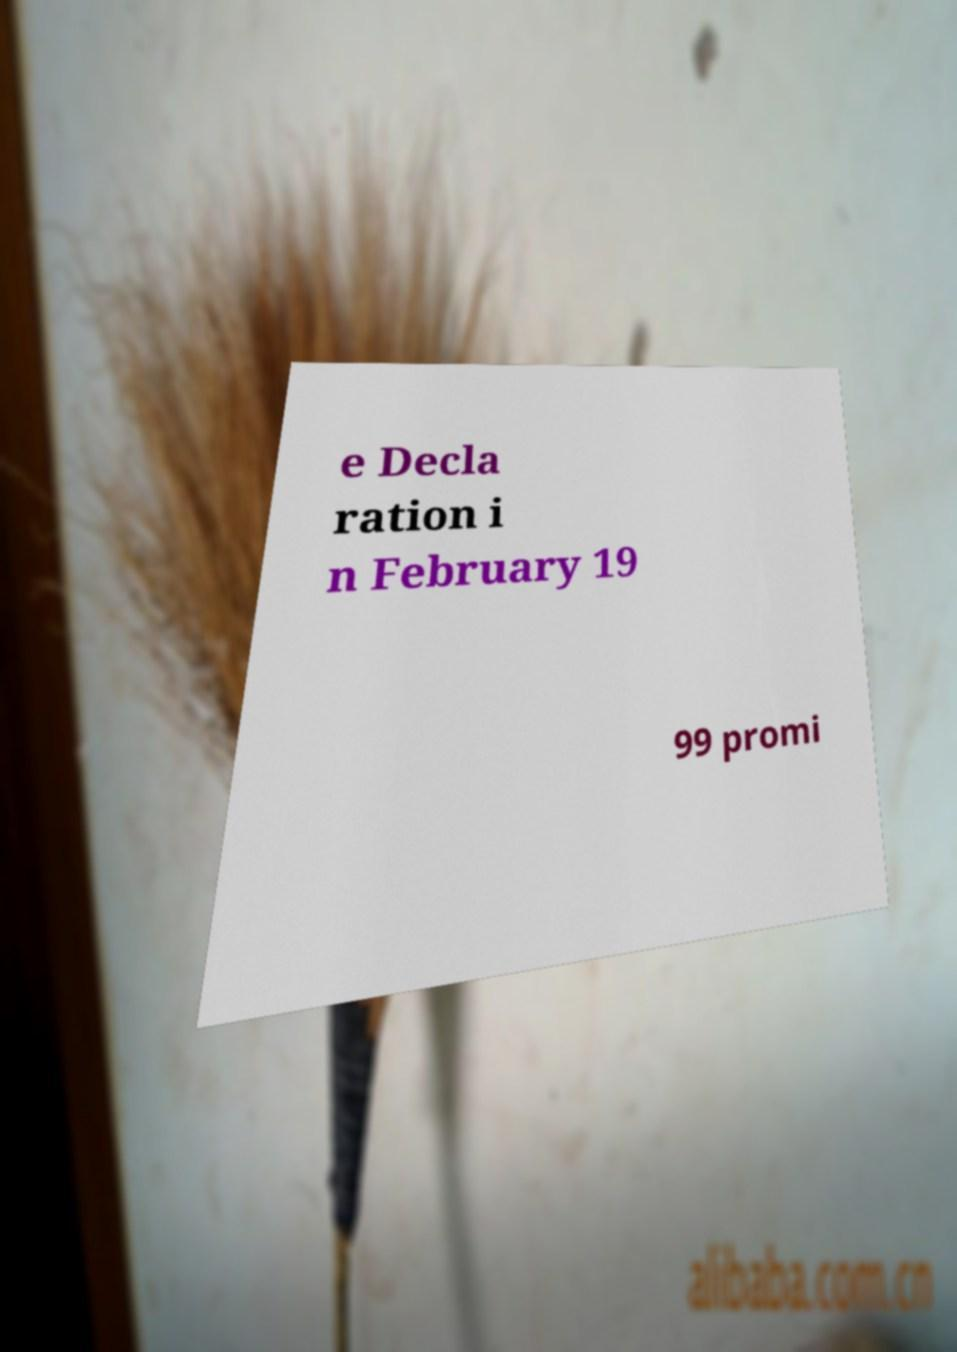What messages or text are displayed in this image? I need them in a readable, typed format. e Decla ration i n February 19 99 promi 